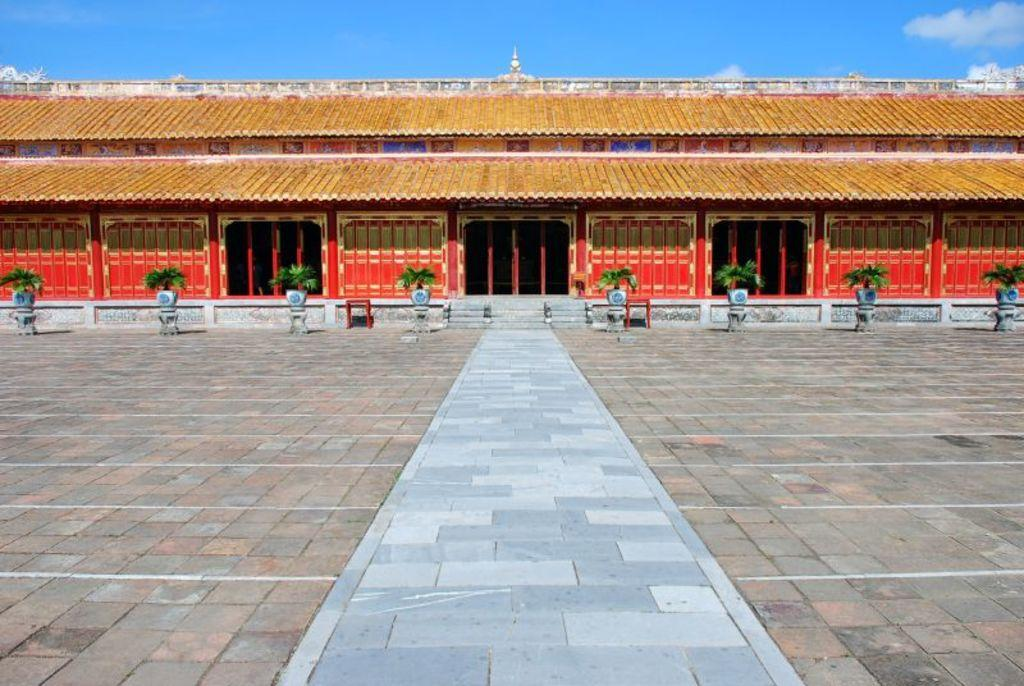What type of structure is present in the image? There is a building in the image. What can be seen near the building? There are flower pots with plants in the image. How are the flower pots positioned? The flower pots are on stools. What is visible in the background of the image? The sky is visible in the background of the image. What type of pin is holding the coat in the image? There is no pin or coat present in the image. 